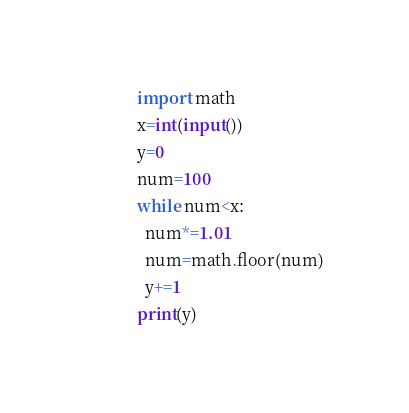Convert code to text. <code><loc_0><loc_0><loc_500><loc_500><_Python_>import math
x=int(input())
y=0
num=100
while num<x:
  num*=1.01
  num=math.floor(num)
  y+=1
print(y)</code> 